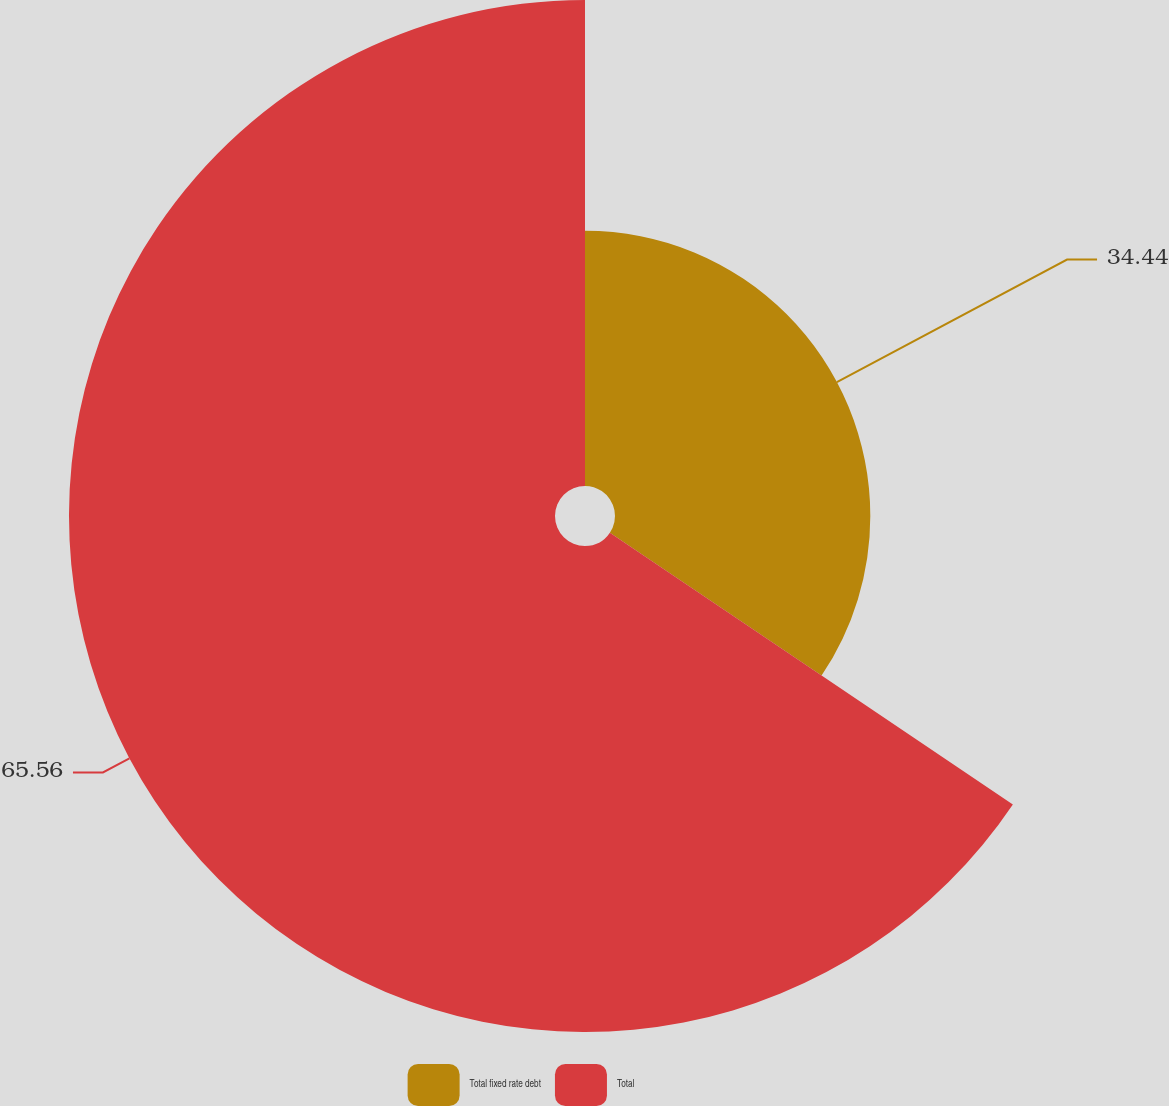Convert chart. <chart><loc_0><loc_0><loc_500><loc_500><pie_chart><fcel>Total fixed rate debt<fcel>Total<nl><fcel>34.44%<fcel>65.56%<nl></chart> 